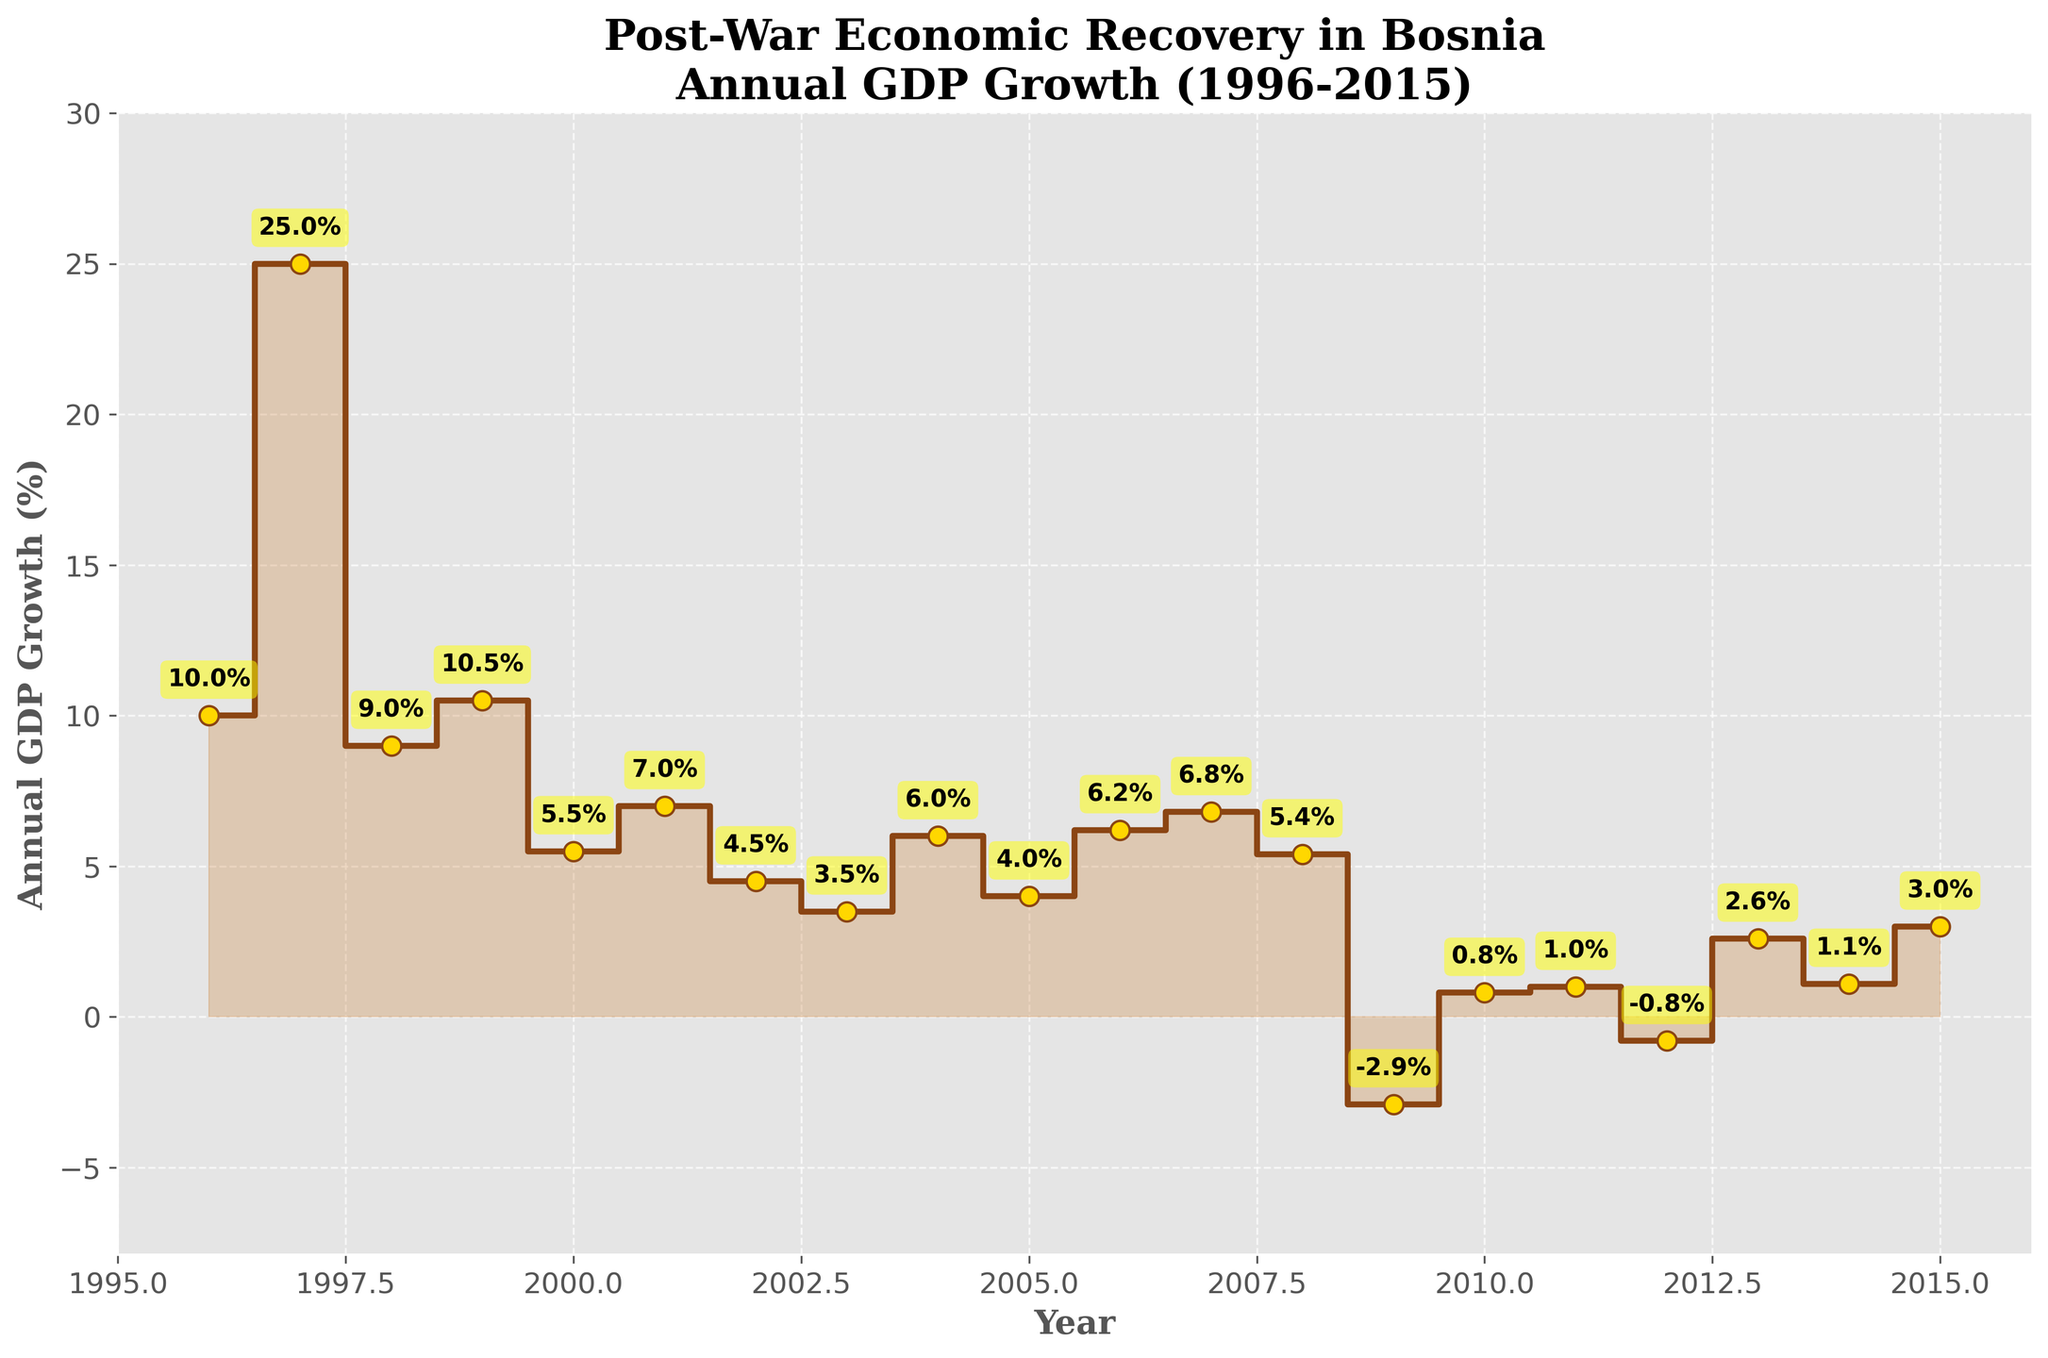What's the title of the plot? The title of the plot is located at the top of the figure in a large, bold font. Reading it directly gives the answer.
Answer: Post-War Economic Recovery in Bosnia Annual GDP Growth (1996-2015) How many data points are shown in the plot? Each year has a corresponding GDP growth value marked by a point. By counting the number of these points, we can determine the number of data points.
Answer: 20 What was the GDP growth in 2009? Locate the point and the label for the year 2009. The label next to the point indicates the GDP growth value.
Answer: -2.9% Which year had the highest GDP growth? By visually scanning the plot, identify the highest point on the y-axis. The year labeled next to this point represents the highest GDP growth.
Answer: 1997 What is the average GDP growth from 1996 to 2000? Sum the GDP growth values from 1996 to 2000 and divide by the number of years (5). Calculations are: (10.0 + 25.0 + 9.0 + 10.5 + 5.5) / 5.
Answer: 12 Which year shows a negative GDP growth after 2008? Identify the points below the 0% line after 2008. The years labeled next to these points represent negative GDP growth.
Answer: 2009 and 2012 How does the GDP growth in 2011 compare to 2010? Check the points for 2010 and 2011 and compare their values. 2010 has 0.8%, and 2011 has 1.0%.
Answer: 2011 was higher What is the range of GDP growth from 1996 to 2015? Subtract the minimum GDP growth value from the maximum GDP growth value. Maximum is 25.0% (1997), and minimum is -2.9% (2009).
Answer: 27.9 Between which successive years do we see the biggest drop in GDP growth? Calculate the GDP growth difference for each pair of successive years and identify the biggest negative change. The biggest drop occurs between 1997 (25.0%) and 1998 (9.0%), a difference of 16.0%.
Answer: 1997 to 1998 What general trend can be observed from 2000 to 2015? Analyze the overall pattern of the GDP growth values from 2000 to 2015. Note if it generally increases, decreases, fluctuates, etc. The trend is generally fluctuating with slight undulations but no sharp continuous increase or decrease.
Answer: Fluctuating 